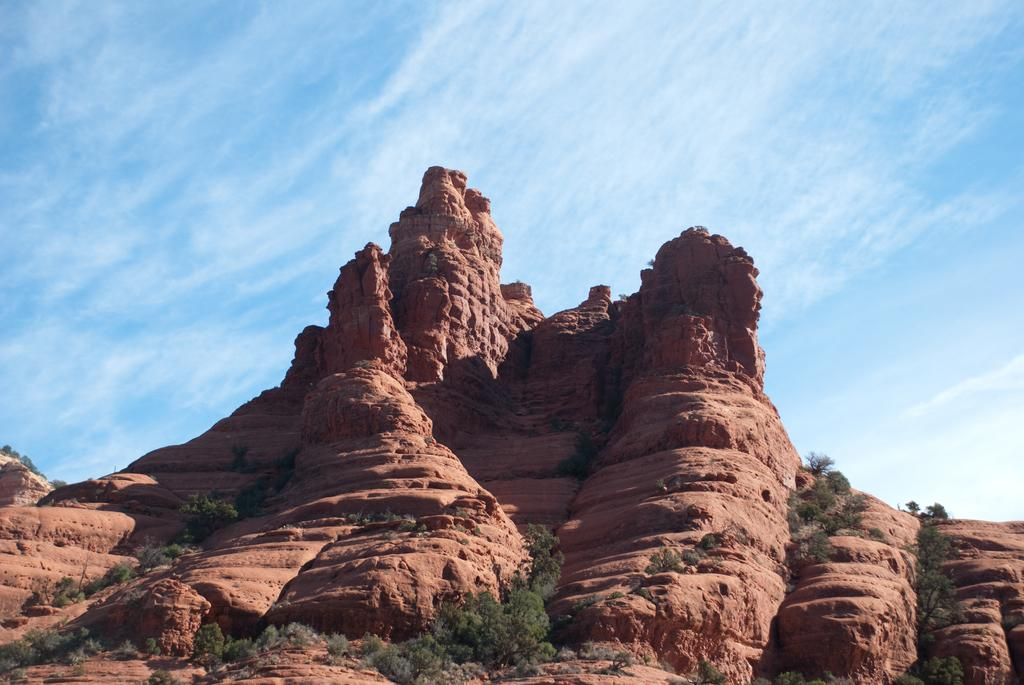What type of vegetation can be seen in the image? There are trees and plants in the image. Where are the trees and plants located? The trees and plants are on a hill. What can be seen in the background of the image? The sky is visible in the background of the image. What type of trousers is the rat wearing in the image? There is no rat or trousers present in the image. Can you describe the stick that the rat is holding in the image? There is no rat or stick present in the image. 